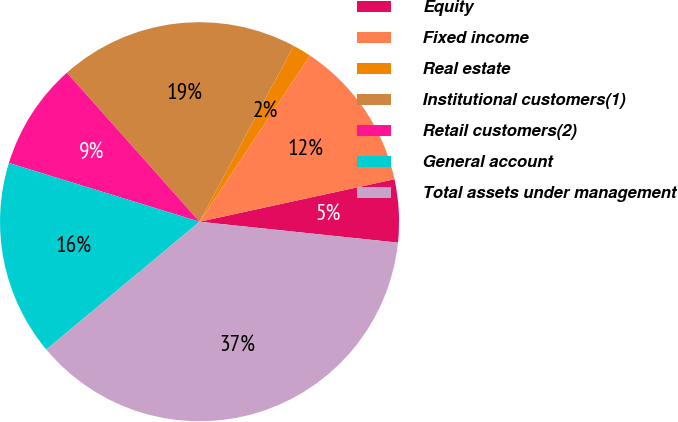Convert chart. <chart><loc_0><loc_0><loc_500><loc_500><pie_chart><fcel>Equity<fcel>Fixed income<fcel>Real estate<fcel>Institutional customers(1)<fcel>Retail customers(2)<fcel>General account<fcel>Total assets under management<nl><fcel>5.09%<fcel>12.24%<fcel>1.52%<fcel>19.39%<fcel>8.67%<fcel>15.82%<fcel>37.26%<nl></chart> 